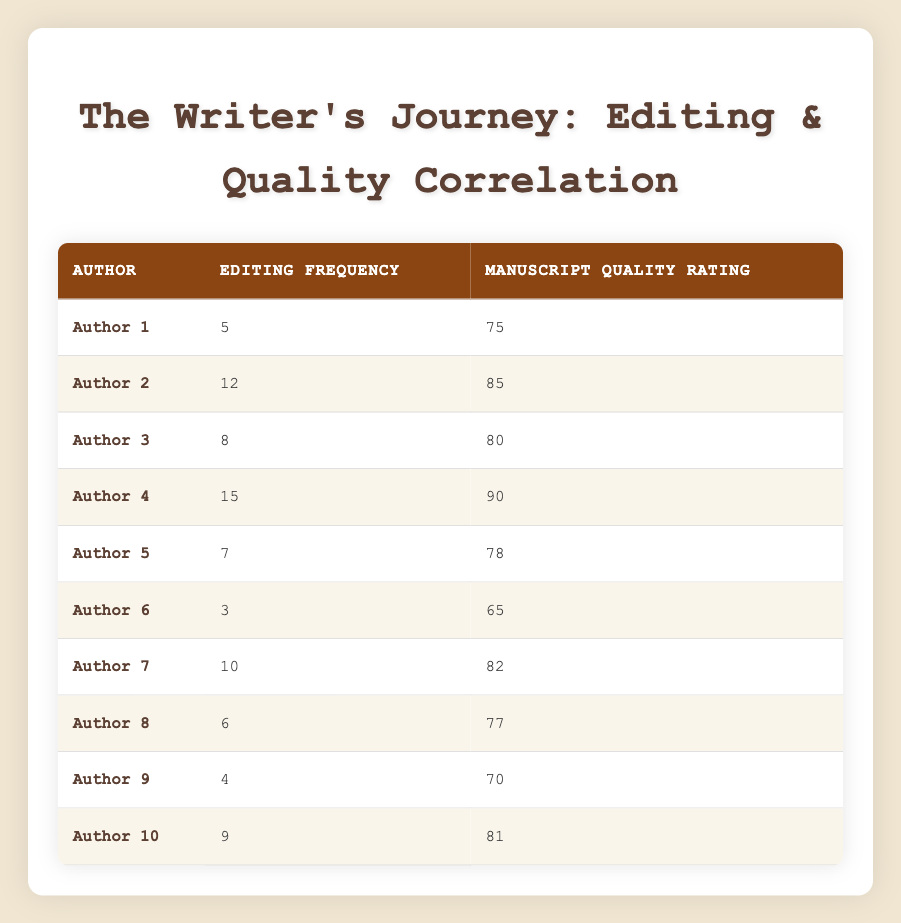What is the editing frequency for Author 4? From the table, we can find that Author 4 has an editing frequency of 15.
Answer: 15 Which author has the highest manuscript quality rating? Looking through the manuscript quality ratings column, Author 4 has the highest rating at 90.
Answer: Author 4 What is the average editing frequency of all authors? To calculate the average, we sum all the editing frequencies: (5 + 12 + 8 + 15 + 7 + 3 + 10 + 6 + 4 + 9) = 79. There are 10 authors, so the average is 79 / 10 = 7.9.
Answer: 7.9 Is there a positive correlation between editing frequency and manuscript quality rating? We can observe that, generally, as editing frequency increases, manuscript quality ratings also tend to increase; for instance, Author 4 has both high editing frequency and high manuscript quality. However, a statistical analysis would provide a precise correlation coefficient, but from the visual inspection, it seems to be positively correlated.
Answer: Yes Which authors have a lower manuscript quality rating than Author 6, who has a rating of 65? Looking at the table, Author 6 has a rating of 65. The authors with lower ratings are Author 1 (75), Author 5 (78), Author 3 (80), Author 9 (70), Author 8 (77), Author 10 (81), and Author 2 (85); none fall below Author 6's rating, making the result none.
Answer: None What is the difference between the editing frequency of Author 2 and Author 7? Author 2 has an editing frequency of 12, and Author 7 has 10. The difference is calculated as 12 - 10 = 2.
Answer: 2 How many authors edit their manuscripts more than 8 times? By checking the editing frequency column, we note that Author 2 (12), Author 4 (15), Author 7 (10), and Author 3 (8) edit more than 8 times. Thus, there are 4 authors who fulfill this criterion.
Answer: 4 What is the median manuscript quality rating among all authors? To find the median, we first list the manuscript quality ratings in order: 65, 70, 75, 77, 78, 80, 81, 82, 85, 90. Since there are 10 ratings (even number), the median is the average of the 5th and 6th values (78 and 80). Thus, (78 + 80) / 2 = 79.
Answer: 79 Which author has an editing frequency of 3, and what is their manuscript quality rating? Author 6 has an editing frequency of 3, and their manuscript quality rating is 65.
Answer: Author 6, 65 